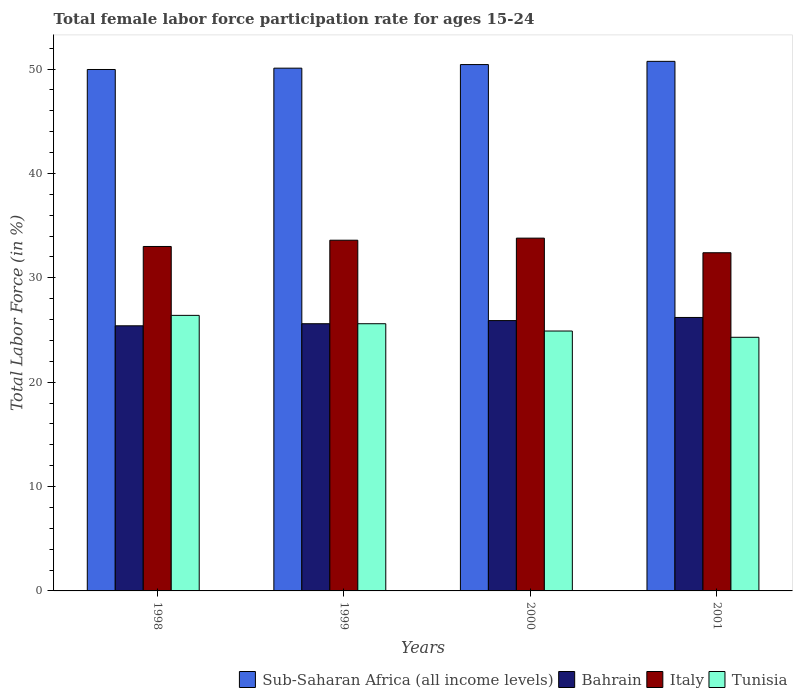How many different coloured bars are there?
Keep it short and to the point. 4. How many groups of bars are there?
Your answer should be compact. 4. Are the number of bars on each tick of the X-axis equal?
Your answer should be very brief. Yes. How many bars are there on the 3rd tick from the right?
Your answer should be compact. 4. What is the female labor force participation rate in Italy in 1999?
Your answer should be compact. 33.6. Across all years, what is the maximum female labor force participation rate in Bahrain?
Your response must be concise. 26.2. Across all years, what is the minimum female labor force participation rate in Sub-Saharan Africa (all income levels)?
Give a very brief answer. 49.96. In which year was the female labor force participation rate in Sub-Saharan Africa (all income levels) maximum?
Offer a terse response. 2001. In which year was the female labor force participation rate in Sub-Saharan Africa (all income levels) minimum?
Offer a very short reply. 1998. What is the total female labor force participation rate in Tunisia in the graph?
Offer a terse response. 101.2. What is the difference between the female labor force participation rate in Bahrain in 2000 and that in 2001?
Your answer should be very brief. -0.3. What is the difference between the female labor force participation rate in Tunisia in 2000 and the female labor force participation rate in Bahrain in 2001?
Offer a very short reply. -1.3. What is the average female labor force participation rate in Tunisia per year?
Your answer should be compact. 25.3. In the year 2000, what is the difference between the female labor force participation rate in Sub-Saharan Africa (all income levels) and female labor force participation rate in Italy?
Your answer should be compact. 16.63. In how many years, is the female labor force participation rate in Sub-Saharan Africa (all income levels) greater than 42 %?
Provide a succinct answer. 4. What is the ratio of the female labor force participation rate in Tunisia in 2000 to that in 2001?
Offer a very short reply. 1.02. What is the difference between the highest and the second highest female labor force participation rate in Sub-Saharan Africa (all income levels)?
Ensure brevity in your answer.  0.31. What is the difference between the highest and the lowest female labor force participation rate in Sub-Saharan Africa (all income levels)?
Ensure brevity in your answer.  0.78. Is the sum of the female labor force participation rate in Sub-Saharan Africa (all income levels) in 1998 and 2000 greater than the maximum female labor force participation rate in Tunisia across all years?
Provide a succinct answer. Yes. What does the 4th bar from the left in 1999 represents?
Ensure brevity in your answer.  Tunisia. What does the 3rd bar from the right in 1998 represents?
Offer a very short reply. Bahrain. Is it the case that in every year, the sum of the female labor force participation rate in Sub-Saharan Africa (all income levels) and female labor force participation rate in Tunisia is greater than the female labor force participation rate in Italy?
Offer a very short reply. Yes. How many bars are there?
Provide a succinct answer. 16. Are all the bars in the graph horizontal?
Your answer should be compact. No. Where does the legend appear in the graph?
Offer a terse response. Bottom right. What is the title of the graph?
Your answer should be very brief. Total female labor force participation rate for ages 15-24. Does "Palau" appear as one of the legend labels in the graph?
Your answer should be very brief. No. What is the label or title of the X-axis?
Offer a very short reply. Years. What is the label or title of the Y-axis?
Make the answer very short. Total Labor Force (in %). What is the Total Labor Force (in %) of Sub-Saharan Africa (all income levels) in 1998?
Provide a short and direct response. 49.96. What is the Total Labor Force (in %) in Bahrain in 1998?
Your answer should be very brief. 25.4. What is the Total Labor Force (in %) in Tunisia in 1998?
Give a very brief answer. 26.4. What is the Total Labor Force (in %) in Sub-Saharan Africa (all income levels) in 1999?
Make the answer very short. 50.08. What is the Total Labor Force (in %) of Bahrain in 1999?
Offer a very short reply. 25.6. What is the Total Labor Force (in %) of Italy in 1999?
Provide a short and direct response. 33.6. What is the Total Labor Force (in %) in Tunisia in 1999?
Make the answer very short. 25.6. What is the Total Labor Force (in %) in Sub-Saharan Africa (all income levels) in 2000?
Your response must be concise. 50.43. What is the Total Labor Force (in %) of Bahrain in 2000?
Keep it short and to the point. 25.9. What is the Total Labor Force (in %) in Italy in 2000?
Your answer should be very brief. 33.8. What is the Total Labor Force (in %) in Tunisia in 2000?
Give a very brief answer. 24.9. What is the Total Labor Force (in %) in Sub-Saharan Africa (all income levels) in 2001?
Offer a very short reply. 50.74. What is the Total Labor Force (in %) of Bahrain in 2001?
Offer a terse response. 26.2. What is the Total Labor Force (in %) in Italy in 2001?
Your response must be concise. 32.4. What is the Total Labor Force (in %) of Tunisia in 2001?
Provide a short and direct response. 24.3. Across all years, what is the maximum Total Labor Force (in %) in Sub-Saharan Africa (all income levels)?
Ensure brevity in your answer.  50.74. Across all years, what is the maximum Total Labor Force (in %) of Bahrain?
Make the answer very short. 26.2. Across all years, what is the maximum Total Labor Force (in %) in Italy?
Ensure brevity in your answer.  33.8. Across all years, what is the maximum Total Labor Force (in %) in Tunisia?
Provide a succinct answer. 26.4. Across all years, what is the minimum Total Labor Force (in %) of Sub-Saharan Africa (all income levels)?
Provide a succinct answer. 49.96. Across all years, what is the minimum Total Labor Force (in %) in Bahrain?
Give a very brief answer. 25.4. Across all years, what is the minimum Total Labor Force (in %) in Italy?
Offer a terse response. 32.4. Across all years, what is the minimum Total Labor Force (in %) in Tunisia?
Your answer should be compact. 24.3. What is the total Total Labor Force (in %) of Sub-Saharan Africa (all income levels) in the graph?
Your answer should be very brief. 201.21. What is the total Total Labor Force (in %) in Bahrain in the graph?
Provide a short and direct response. 103.1. What is the total Total Labor Force (in %) in Italy in the graph?
Your response must be concise. 132.8. What is the total Total Labor Force (in %) of Tunisia in the graph?
Offer a very short reply. 101.2. What is the difference between the Total Labor Force (in %) of Sub-Saharan Africa (all income levels) in 1998 and that in 1999?
Provide a succinct answer. -0.13. What is the difference between the Total Labor Force (in %) of Bahrain in 1998 and that in 1999?
Give a very brief answer. -0.2. What is the difference between the Total Labor Force (in %) of Italy in 1998 and that in 1999?
Provide a short and direct response. -0.6. What is the difference between the Total Labor Force (in %) of Tunisia in 1998 and that in 1999?
Provide a short and direct response. 0.8. What is the difference between the Total Labor Force (in %) of Sub-Saharan Africa (all income levels) in 1998 and that in 2000?
Your answer should be very brief. -0.47. What is the difference between the Total Labor Force (in %) of Italy in 1998 and that in 2000?
Keep it short and to the point. -0.8. What is the difference between the Total Labor Force (in %) in Tunisia in 1998 and that in 2000?
Your response must be concise. 1.5. What is the difference between the Total Labor Force (in %) of Sub-Saharan Africa (all income levels) in 1998 and that in 2001?
Keep it short and to the point. -0.78. What is the difference between the Total Labor Force (in %) of Bahrain in 1998 and that in 2001?
Ensure brevity in your answer.  -0.8. What is the difference between the Total Labor Force (in %) of Tunisia in 1998 and that in 2001?
Keep it short and to the point. 2.1. What is the difference between the Total Labor Force (in %) in Sub-Saharan Africa (all income levels) in 1999 and that in 2000?
Your answer should be compact. -0.35. What is the difference between the Total Labor Force (in %) of Bahrain in 1999 and that in 2000?
Your answer should be very brief. -0.3. What is the difference between the Total Labor Force (in %) of Tunisia in 1999 and that in 2000?
Keep it short and to the point. 0.7. What is the difference between the Total Labor Force (in %) of Sub-Saharan Africa (all income levels) in 1999 and that in 2001?
Provide a succinct answer. -0.65. What is the difference between the Total Labor Force (in %) of Bahrain in 1999 and that in 2001?
Provide a short and direct response. -0.6. What is the difference between the Total Labor Force (in %) of Italy in 1999 and that in 2001?
Your response must be concise. 1.2. What is the difference between the Total Labor Force (in %) in Sub-Saharan Africa (all income levels) in 2000 and that in 2001?
Ensure brevity in your answer.  -0.31. What is the difference between the Total Labor Force (in %) of Bahrain in 2000 and that in 2001?
Your answer should be compact. -0.3. What is the difference between the Total Labor Force (in %) of Italy in 2000 and that in 2001?
Provide a short and direct response. 1.4. What is the difference between the Total Labor Force (in %) in Tunisia in 2000 and that in 2001?
Provide a short and direct response. 0.6. What is the difference between the Total Labor Force (in %) in Sub-Saharan Africa (all income levels) in 1998 and the Total Labor Force (in %) in Bahrain in 1999?
Your response must be concise. 24.36. What is the difference between the Total Labor Force (in %) of Sub-Saharan Africa (all income levels) in 1998 and the Total Labor Force (in %) of Italy in 1999?
Provide a short and direct response. 16.36. What is the difference between the Total Labor Force (in %) of Sub-Saharan Africa (all income levels) in 1998 and the Total Labor Force (in %) of Tunisia in 1999?
Your answer should be compact. 24.36. What is the difference between the Total Labor Force (in %) in Bahrain in 1998 and the Total Labor Force (in %) in Italy in 1999?
Ensure brevity in your answer.  -8.2. What is the difference between the Total Labor Force (in %) in Sub-Saharan Africa (all income levels) in 1998 and the Total Labor Force (in %) in Bahrain in 2000?
Your answer should be compact. 24.06. What is the difference between the Total Labor Force (in %) of Sub-Saharan Africa (all income levels) in 1998 and the Total Labor Force (in %) of Italy in 2000?
Provide a short and direct response. 16.16. What is the difference between the Total Labor Force (in %) in Sub-Saharan Africa (all income levels) in 1998 and the Total Labor Force (in %) in Tunisia in 2000?
Give a very brief answer. 25.06. What is the difference between the Total Labor Force (in %) in Bahrain in 1998 and the Total Labor Force (in %) in Italy in 2000?
Your answer should be compact. -8.4. What is the difference between the Total Labor Force (in %) in Sub-Saharan Africa (all income levels) in 1998 and the Total Labor Force (in %) in Bahrain in 2001?
Provide a short and direct response. 23.76. What is the difference between the Total Labor Force (in %) in Sub-Saharan Africa (all income levels) in 1998 and the Total Labor Force (in %) in Italy in 2001?
Your response must be concise. 17.56. What is the difference between the Total Labor Force (in %) of Sub-Saharan Africa (all income levels) in 1998 and the Total Labor Force (in %) of Tunisia in 2001?
Provide a succinct answer. 25.66. What is the difference between the Total Labor Force (in %) in Bahrain in 1998 and the Total Labor Force (in %) in Italy in 2001?
Provide a short and direct response. -7. What is the difference between the Total Labor Force (in %) in Italy in 1998 and the Total Labor Force (in %) in Tunisia in 2001?
Ensure brevity in your answer.  8.7. What is the difference between the Total Labor Force (in %) of Sub-Saharan Africa (all income levels) in 1999 and the Total Labor Force (in %) of Bahrain in 2000?
Provide a succinct answer. 24.18. What is the difference between the Total Labor Force (in %) in Sub-Saharan Africa (all income levels) in 1999 and the Total Labor Force (in %) in Italy in 2000?
Provide a short and direct response. 16.28. What is the difference between the Total Labor Force (in %) in Sub-Saharan Africa (all income levels) in 1999 and the Total Labor Force (in %) in Tunisia in 2000?
Provide a succinct answer. 25.18. What is the difference between the Total Labor Force (in %) in Bahrain in 1999 and the Total Labor Force (in %) in Italy in 2000?
Provide a short and direct response. -8.2. What is the difference between the Total Labor Force (in %) in Sub-Saharan Africa (all income levels) in 1999 and the Total Labor Force (in %) in Bahrain in 2001?
Ensure brevity in your answer.  23.88. What is the difference between the Total Labor Force (in %) of Sub-Saharan Africa (all income levels) in 1999 and the Total Labor Force (in %) of Italy in 2001?
Provide a short and direct response. 17.68. What is the difference between the Total Labor Force (in %) in Sub-Saharan Africa (all income levels) in 1999 and the Total Labor Force (in %) in Tunisia in 2001?
Give a very brief answer. 25.78. What is the difference between the Total Labor Force (in %) in Bahrain in 1999 and the Total Labor Force (in %) in Tunisia in 2001?
Keep it short and to the point. 1.3. What is the difference between the Total Labor Force (in %) in Sub-Saharan Africa (all income levels) in 2000 and the Total Labor Force (in %) in Bahrain in 2001?
Ensure brevity in your answer.  24.23. What is the difference between the Total Labor Force (in %) in Sub-Saharan Africa (all income levels) in 2000 and the Total Labor Force (in %) in Italy in 2001?
Your answer should be very brief. 18.03. What is the difference between the Total Labor Force (in %) of Sub-Saharan Africa (all income levels) in 2000 and the Total Labor Force (in %) of Tunisia in 2001?
Offer a very short reply. 26.13. What is the average Total Labor Force (in %) in Sub-Saharan Africa (all income levels) per year?
Offer a very short reply. 50.3. What is the average Total Labor Force (in %) of Bahrain per year?
Provide a succinct answer. 25.77. What is the average Total Labor Force (in %) in Italy per year?
Offer a terse response. 33.2. What is the average Total Labor Force (in %) in Tunisia per year?
Your answer should be very brief. 25.3. In the year 1998, what is the difference between the Total Labor Force (in %) of Sub-Saharan Africa (all income levels) and Total Labor Force (in %) of Bahrain?
Your response must be concise. 24.56. In the year 1998, what is the difference between the Total Labor Force (in %) in Sub-Saharan Africa (all income levels) and Total Labor Force (in %) in Italy?
Provide a succinct answer. 16.96. In the year 1998, what is the difference between the Total Labor Force (in %) in Sub-Saharan Africa (all income levels) and Total Labor Force (in %) in Tunisia?
Your answer should be compact. 23.56. In the year 1998, what is the difference between the Total Labor Force (in %) in Bahrain and Total Labor Force (in %) in Italy?
Make the answer very short. -7.6. In the year 1999, what is the difference between the Total Labor Force (in %) of Sub-Saharan Africa (all income levels) and Total Labor Force (in %) of Bahrain?
Provide a succinct answer. 24.48. In the year 1999, what is the difference between the Total Labor Force (in %) in Sub-Saharan Africa (all income levels) and Total Labor Force (in %) in Italy?
Ensure brevity in your answer.  16.48. In the year 1999, what is the difference between the Total Labor Force (in %) of Sub-Saharan Africa (all income levels) and Total Labor Force (in %) of Tunisia?
Your answer should be very brief. 24.48. In the year 1999, what is the difference between the Total Labor Force (in %) in Bahrain and Total Labor Force (in %) in Italy?
Provide a succinct answer. -8. In the year 1999, what is the difference between the Total Labor Force (in %) of Italy and Total Labor Force (in %) of Tunisia?
Keep it short and to the point. 8. In the year 2000, what is the difference between the Total Labor Force (in %) of Sub-Saharan Africa (all income levels) and Total Labor Force (in %) of Bahrain?
Keep it short and to the point. 24.53. In the year 2000, what is the difference between the Total Labor Force (in %) in Sub-Saharan Africa (all income levels) and Total Labor Force (in %) in Italy?
Ensure brevity in your answer.  16.63. In the year 2000, what is the difference between the Total Labor Force (in %) of Sub-Saharan Africa (all income levels) and Total Labor Force (in %) of Tunisia?
Offer a terse response. 25.53. In the year 2000, what is the difference between the Total Labor Force (in %) of Bahrain and Total Labor Force (in %) of Italy?
Provide a short and direct response. -7.9. In the year 2001, what is the difference between the Total Labor Force (in %) in Sub-Saharan Africa (all income levels) and Total Labor Force (in %) in Bahrain?
Offer a terse response. 24.54. In the year 2001, what is the difference between the Total Labor Force (in %) of Sub-Saharan Africa (all income levels) and Total Labor Force (in %) of Italy?
Provide a short and direct response. 18.34. In the year 2001, what is the difference between the Total Labor Force (in %) in Sub-Saharan Africa (all income levels) and Total Labor Force (in %) in Tunisia?
Your answer should be compact. 26.44. What is the ratio of the Total Labor Force (in %) in Sub-Saharan Africa (all income levels) in 1998 to that in 1999?
Your response must be concise. 1. What is the ratio of the Total Labor Force (in %) of Italy in 1998 to that in 1999?
Provide a succinct answer. 0.98. What is the ratio of the Total Labor Force (in %) of Tunisia in 1998 to that in 1999?
Your answer should be very brief. 1.03. What is the ratio of the Total Labor Force (in %) in Sub-Saharan Africa (all income levels) in 1998 to that in 2000?
Your answer should be compact. 0.99. What is the ratio of the Total Labor Force (in %) of Bahrain in 1998 to that in 2000?
Ensure brevity in your answer.  0.98. What is the ratio of the Total Labor Force (in %) in Italy in 1998 to that in 2000?
Keep it short and to the point. 0.98. What is the ratio of the Total Labor Force (in %) of Tunisia in 1998 to that in 2000?
Your answer should be very brief. 1.06. What is the ratio of the Total Labor Force (in %) of Sub-Saharan Africa (all income levels) in 1998 to that in 2001?
Ensure brevity in your answer.  0.98. What is the ratio of the Total Labor Force (in %) in Bahrain in 1998 to that in 2001?
Your answer should be very brief. 0.97. What is the ratio of the Total Labor Force (in %) in Italy in 1998 to that in 2001?
Offer a very short reply. 1.02. What is the ratio of the Total Labor Force (in %) of Tunisia in 1998 to that in 2001?
Your answer should be very brief. 1.09. What is the ratio of the Total Labor Force (in %) in Bahrain in 1999 to that in 2000?
Offer a very short reply. 0.99. What is the ratio of the Total Labor Force (in %) of Tunisia in 1999 to that in 2000?
Ensure brevity in your answer.  1.03. What is the ratio of the Total Labor Force (in %) in Sub-Saharan Africa (all income levels) in 1999 to that in 2001?
Your response must be concise. 0.99. What is the ratio of the Total Labor Force (in %) of Bahrain in 1999 to that in 2001?
Make the answer very short. 0.98. What is the ratio of the Total Labor Force (in %) in Tunisia in 1999 to that in 2001?
Offer a very short reply. 1.05. What is the ratio of the Total Labor Force (in %) of Bahrain in 2000 to that in 2001?
Offer a very short reply. 0.99. What is the ratio of the Total Labor Force (in %) of Italy in 2000 to that in 2001?
Ensure brevity in your answer.  1.04. What is the ratio of the Total Labor Force (in %) in Tunisia in 2000 to that in 2001?
Give a very brief answer. 1.02. What is the difference between the highest and the second highest Total Labor Force (in %) in Sub-Saharan Africa (all income levels)?
Ensure brevity in your answer.  0.31. What is the difference between the highest and the second highest Total Labor Force (in %) of Bahrain?
Make the answer very short. 0.3. What is the difference between the highest and the second highest Total Labor Force (in %) in Tunisia?
Your response must be concise. 0.8. What is the difference between the highest and the lowest Total Labor Force (in %) in Sub-Saharan Africa (all income levels)?
Offer a very short reply. 0.78. What is the difference between the highest and the lowest Total Labor Force (in %) in Bahrain?
Give a very brief answer. 0.8. What is the difference between the highest and the lowest Total Labor Force (in %) in Tunisia?
Provide a short and direct response. 2.1. 